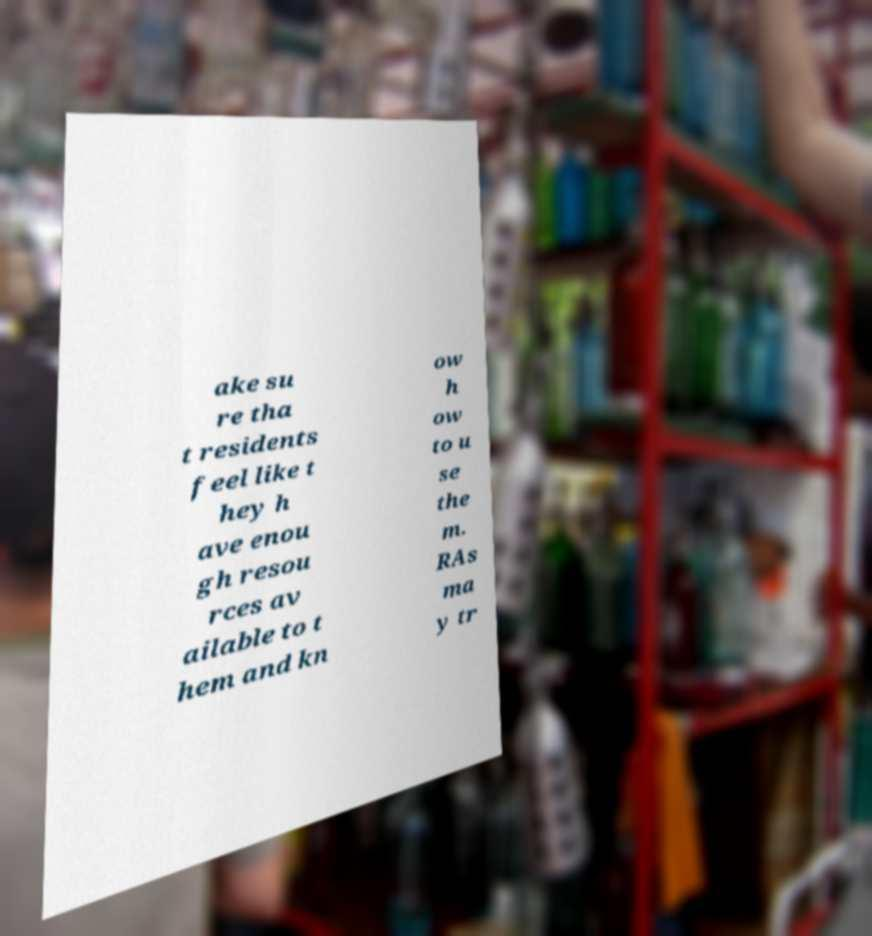What messages or text are displayed in this image? I need them in a readable, typed format. ake su re tha t residents feel like t hey h ave enou gh resou rces av ailable to t hem and kn ow h ow to u se the m. RAs ma y tr 